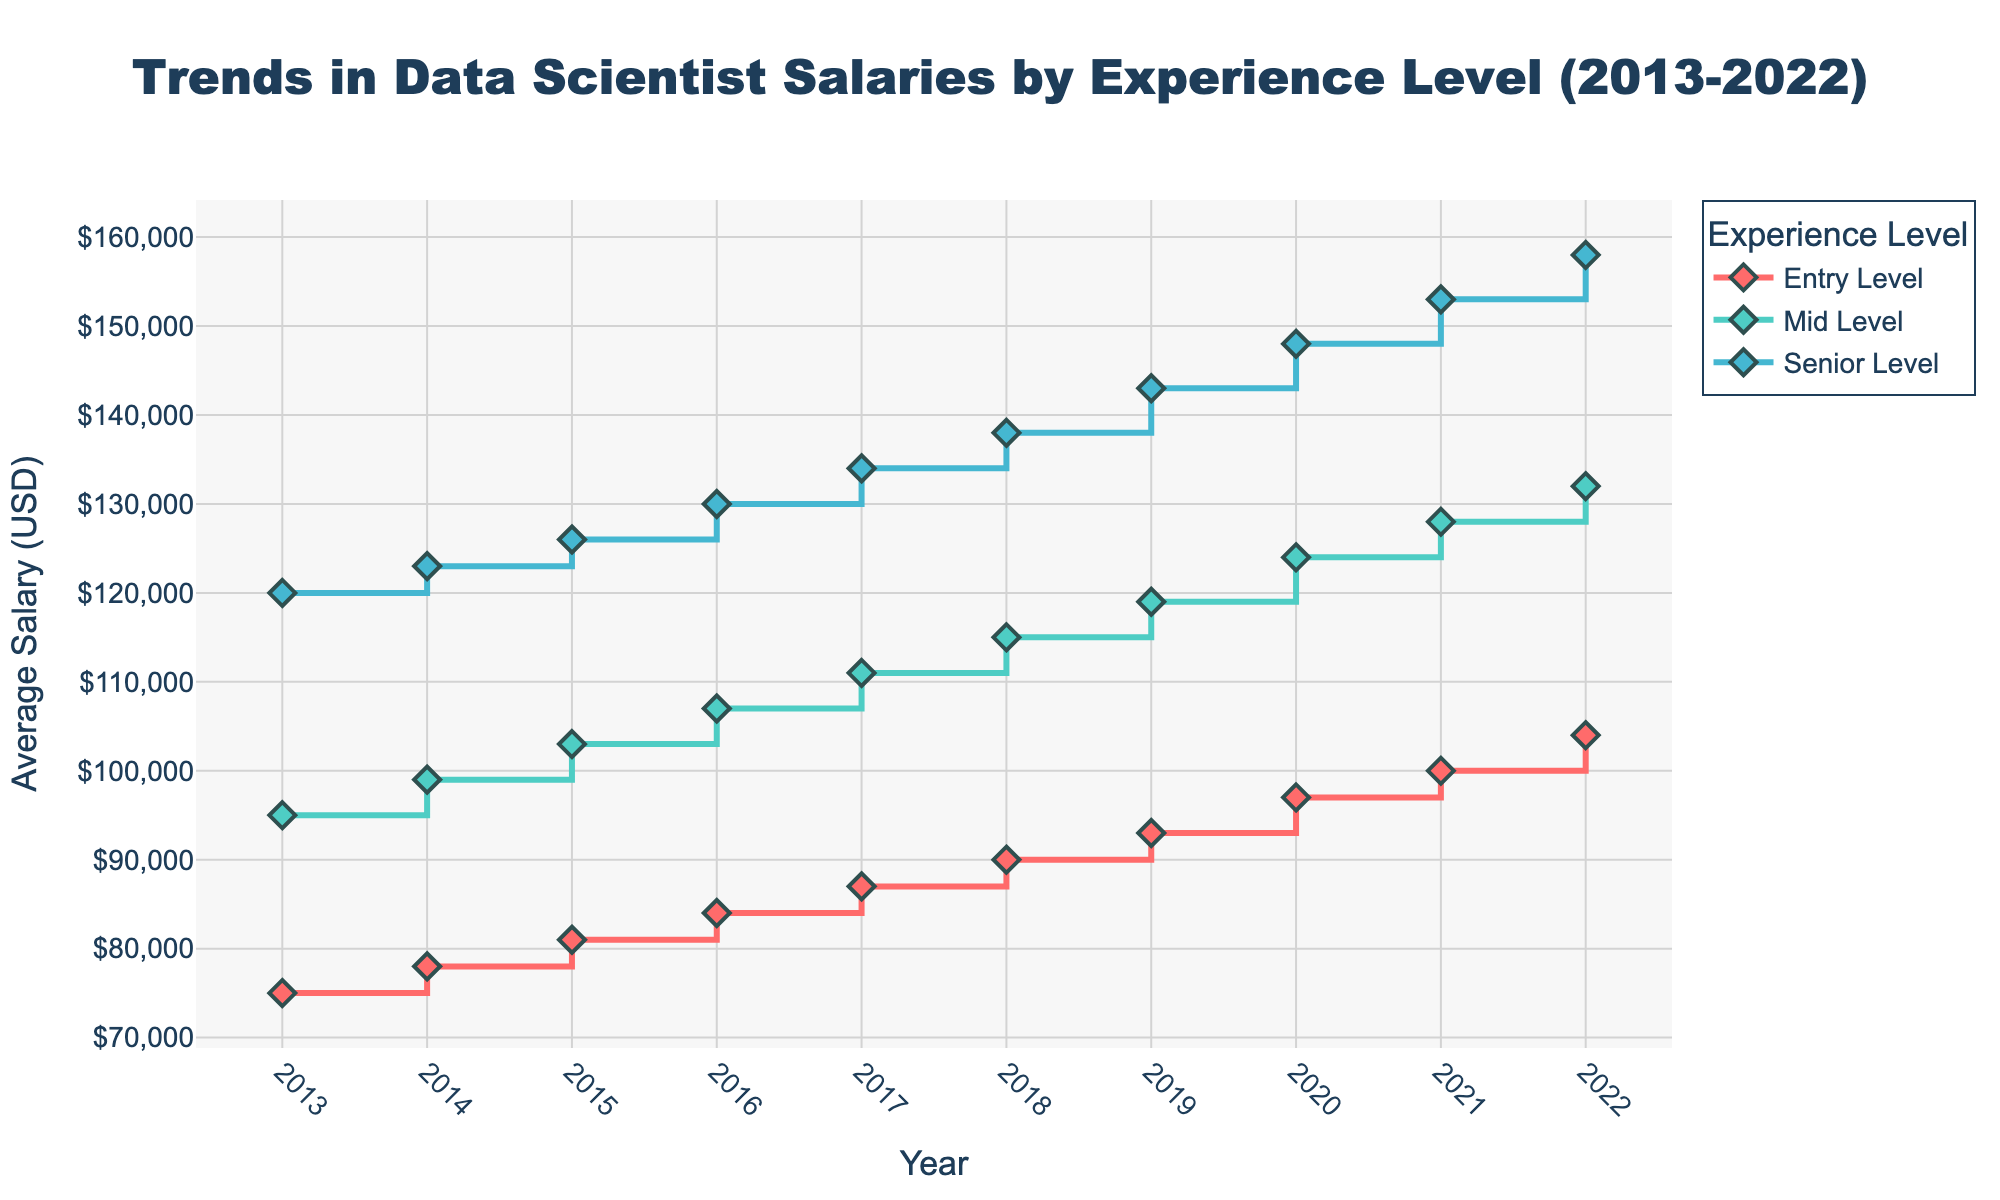What is the title of the figure? The title of the figure is shown at the top of the plot. It reads "Trends in Data Scientist Salaries by Experience Level (2013-2022)."
Answer: Trends in Data Scientist Salaries by Experience Level (2013-2022) What is the color used for the Senior Level experience? The Senior Level experience is represented by the middle line in the list of colors used for each level. The colors are listed in order, with the third color '#45B7D1' (a shade of blue) representing the Senior Level.
Answer: Blue How much did the average salary for Mid Level experience increase from 2013 to 2022? Look at the Mid Level line (green) at both ends of the x-axis. In 2013, it is at $95,000, and in 2022, it is at $132,000. The increase is $132,000 - $95,000 = $37,000.
Answer: $37,000 What year did the Entry Level average salary first exceed $90,000? Trace the Entry Level line (red) along the x-axis until it surpasses $90,000. This occurs in 2018 when it reaches $90,000.
Answer: 2018 In which year did Senior Level salaries see the largest year-over-year increase? Compare the heights of the steps in the Senior Level line (blue) where the biggest jump occurred. From 2019 to 2020, there is the largest increase from $143,000 to $148,000, making it a $5,000 increase.
Answer: 2020 Which experience level had the highest average salary in 2022 and what was it? Look at the 2022 data points and compare the end values. The Senior Level line (blue) is the highest, marking $158,000.
Answer: Senior Level, $158,000 How many years of data are displayed in the figure? The x-axis ranges from 2013 to 2022. Counting these years shows there are ten data points.
Answer: 10 By how much did the average salary for Entry Level increase from 2013 to 2015? Check the Entry Level line (red) from 2013 ($75,000) to 2015 ($81,000). The increase is $81,000 - $75,000 = $6,000.
Answer: $6,000 Which experience level shows the most consistent increase in salaries over the period? Observe the smoothness and evenness of the step heights in each line. The Mid Level line (green) shows the most consistent increases with a regular upward trend.
Answer: Mid Level In what year does the gap between Entry Level and Senior Level salaries appear the smallest? Compare the vertical gaps between Entry Level (red) and Senior Level (blue) lines each year. The smallest gap appears in 2013.
Answer: 2013 